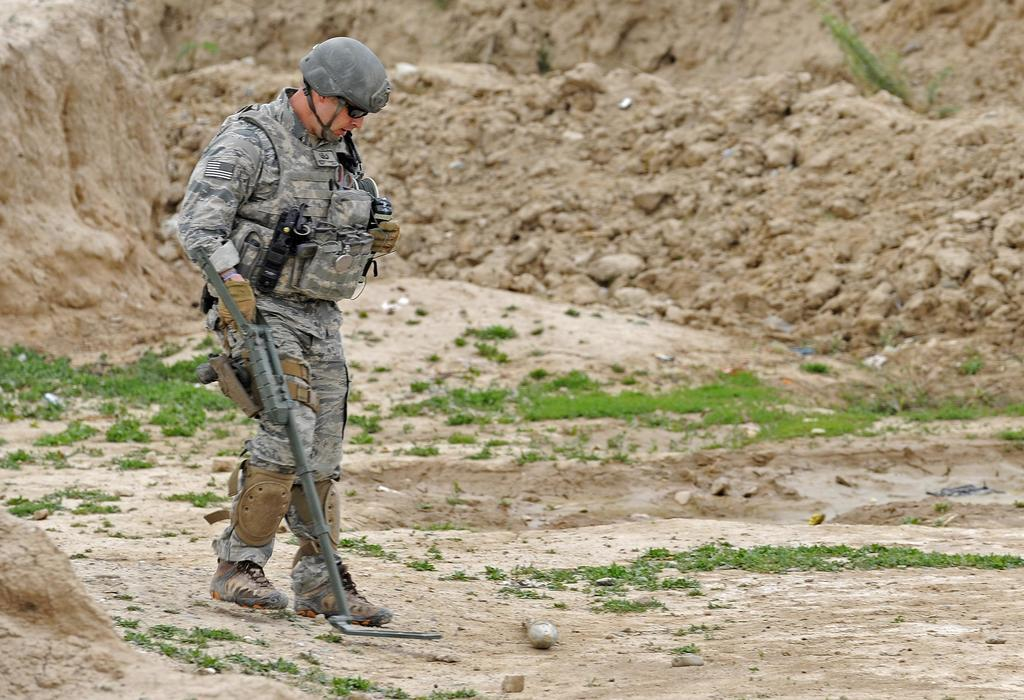What is the main subject of the image? There is a man in the image. What is the man doing in the image? The man is walking and holding an object. What can be seen in the background of the image? There is mud in the background of the image. What type of vegetation is at the bottom of the image? There is grass at the bottom of the image. What type of meat can be seen hanging from a stick in the image? There is no meat or stick present in the image. 